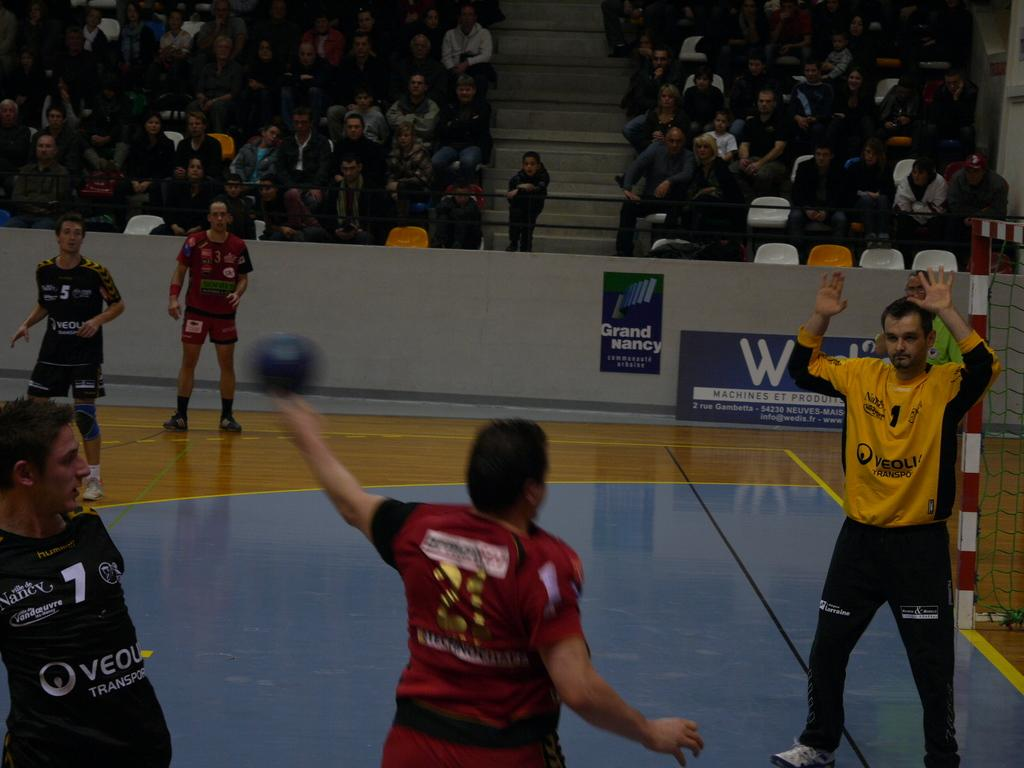<image>
Give a short and clear explanation of the subsequent image. Player number 1 wears a yellow jersey and holds both of his hands up. 